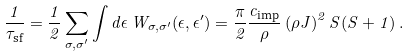<formula> <loc_0><loc_0><loc_500><loc_500>\frac { 1 } { \tau _ { \text {sf} } } = \frac { 1 } { 2 } \sum _ { \sigma , \sigma ^ { \prime } } \int d \epsilon \, W _ { \sigma , \sigma ^ { \prime } } ( \epsilon , \epsilon ^ { \prime } ) = \frac { \pi } { 2 } \frac { c _ { \text {imp} } } { \rho } \left ( \rho J \right ) ^ { 2 } S ( S + 1 ) \, .</formula> 